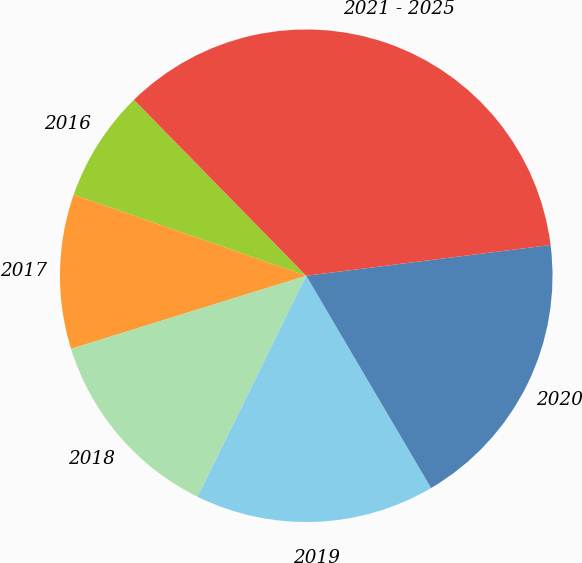Convert chart. <chart><loc_0><loc_0><loc_500><loc_500><pie_chart><fcel>2016<fcel>2017<fcel>2018<fcel>2019<fcel>2020<fcel>2021 - 2025<nl><fcel>7.33%<fcel>10.13%<fcel>12.93%<fcel>15.73%<fcel>18.53%<fcel>35.33%<nl></chart> 